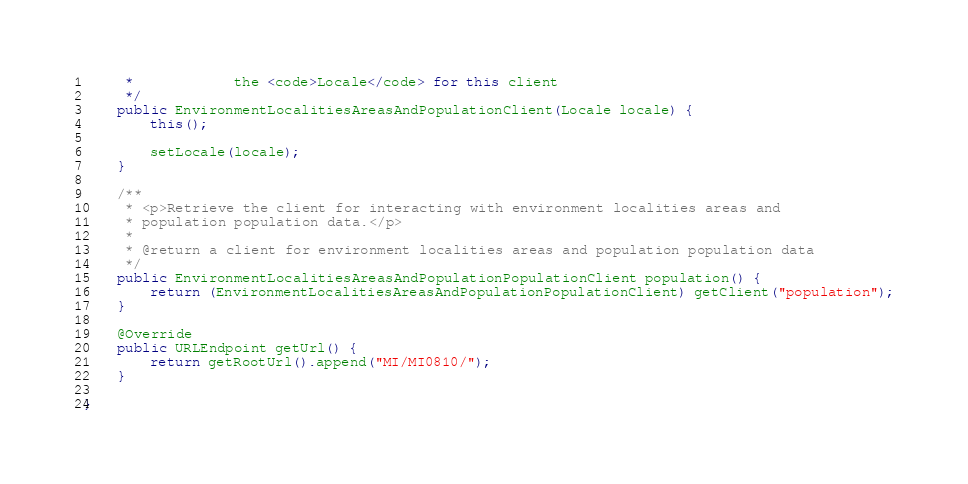<code> <loc_0><loc_0><loc_500><loc_500><_Java_>     *            the <code>Locale</code> for this client
     */
    public EnvironmentLocalitiesAreasAndPopulationClient(Locale locale) {
        this();

        setLocale(locale);
    }

    /**
     * <p>Retrieve the client for interacting with environment localities areas and
     * population population data.</p>
     *
     * @return a client for environment localities areas and population population data
     */
    public EnvironmentLocalitiesAreasAndPopulationPopulationClient population() {
        return (EnvironmentLocalitiesAreasAndPopulationPopulationClient) getClient("population");
    }

    @Override
    public URLEndpoint getUrl() {
        return getRootUrl().append("MI/MI0810/");
    }

}
</code> 